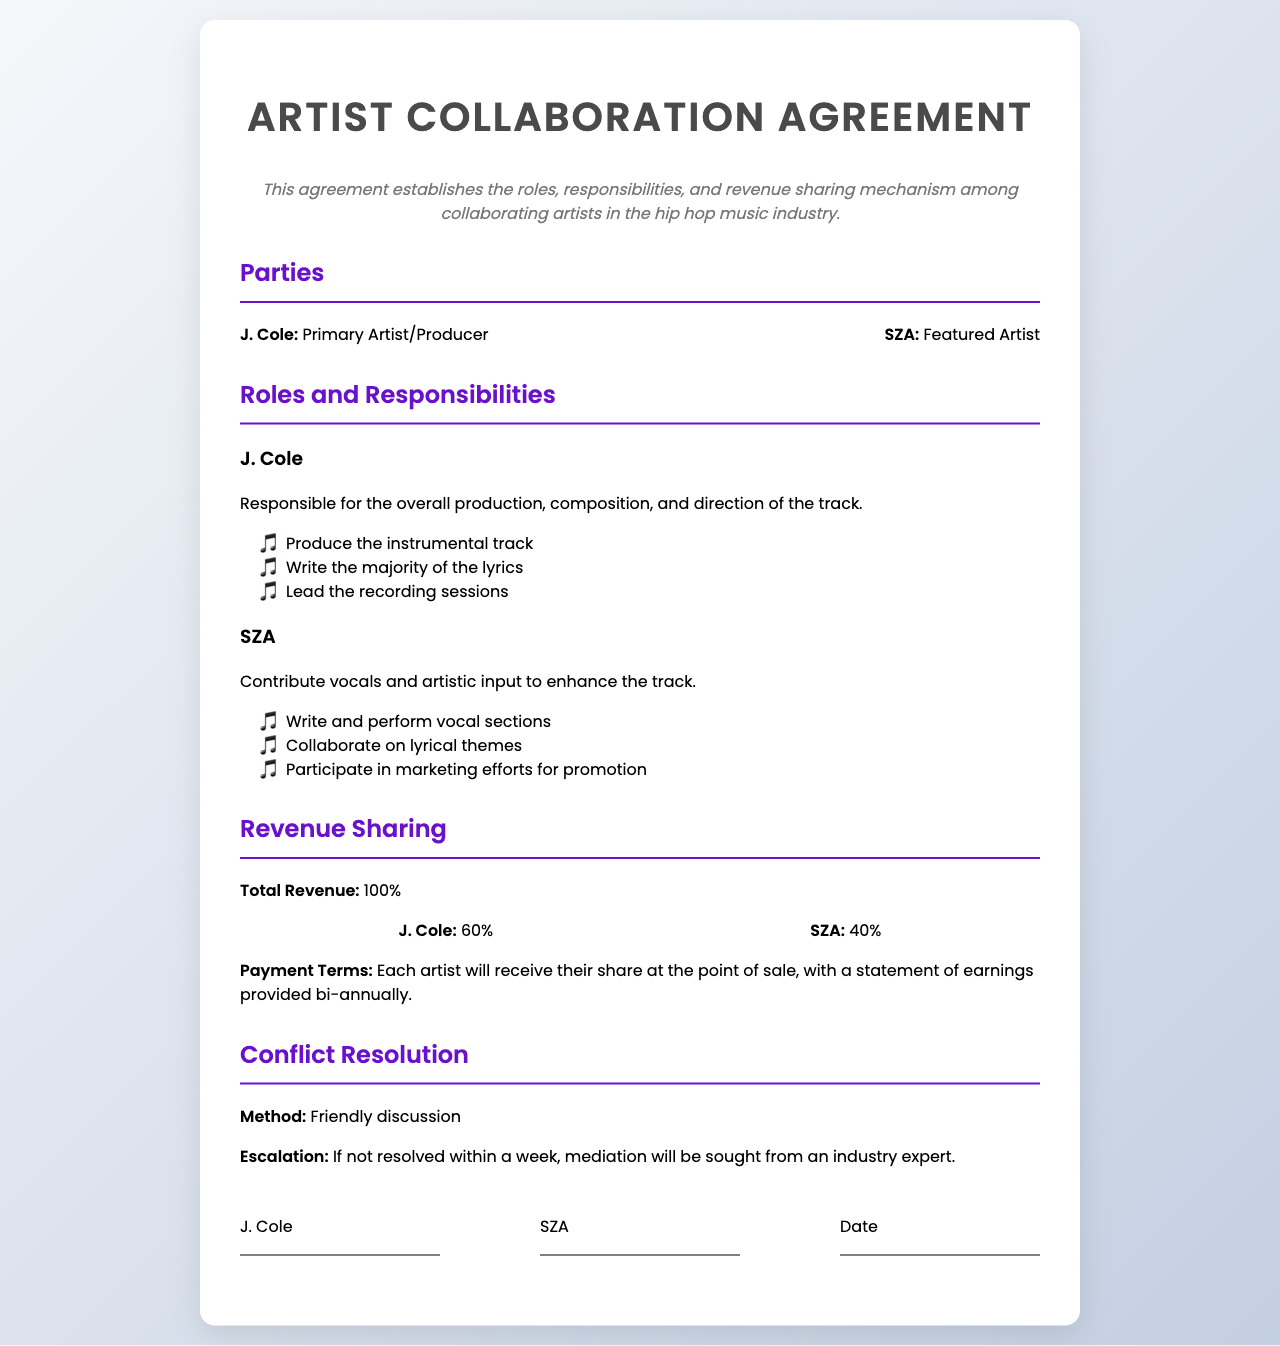what is the name of the primary artist? The document lists J. Cole as the primary artist/producer.
Answer: J. Cole what is the revenue share percentage for SZA? The document specifies that SZA receives 40% of the revenue.
Answer: 40% who is responsible for producing the instrumental track? J. Cole is responsible for producing the instrumental track, as mentioned in his duties.
Answer: J. Cole what is the total revenue stated in the document? The document indicates the total revenue is 100%.
Answer: 100% how will payments be made to the artists? The payment terms state that each artist will receive their share at the point of sale.
Answer: At the point of sale what method is used for conflict resolution? The document mentions that conflict resolution will start with a friendly discussion.
Answer: Friendly discussion how many duties are listed for SZA? There are three duties listed for SZA in the document.
Answer: Three what is the escalation process if the conflict is not resolved? If the conflict is not resolved within a week, mediation will be sought from an industry expert.
Answer: Mediation who signs the agreement? The agreement is signed by J. Cole and SZA.
Answer: J. Cole and SZA 